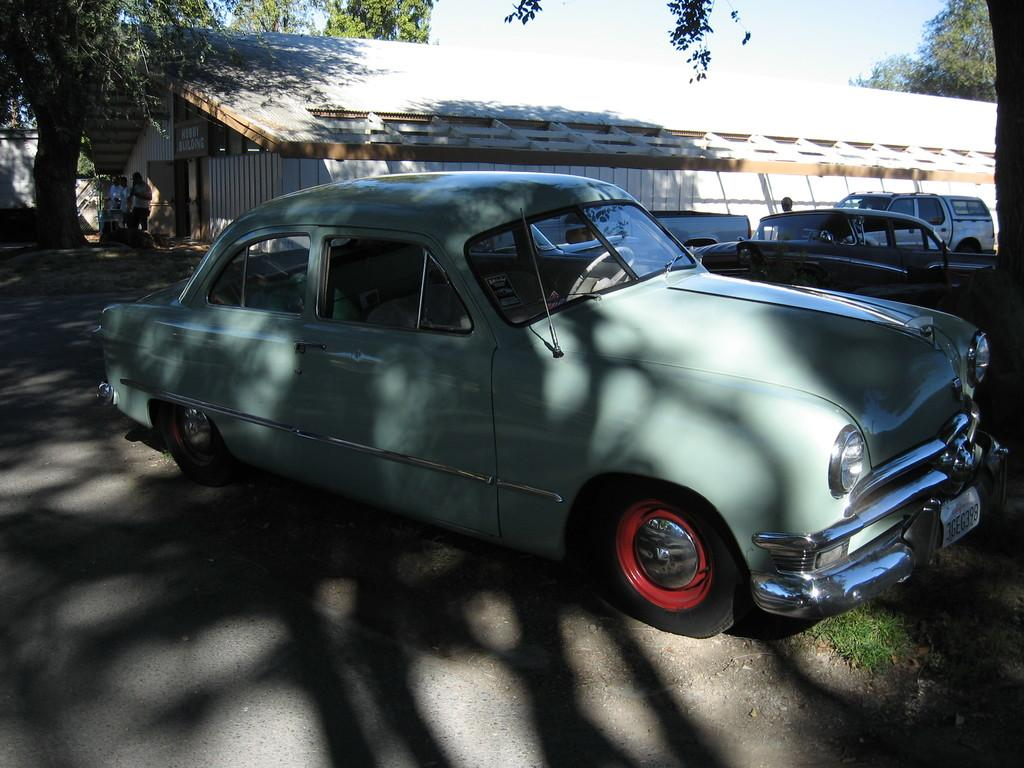What types of objects are on the ground in the image? There are vehicles on the ground in the image. What can be seen in the background of the image? In the background of the image, there are persons, trees, a board on a wall, a roof, and clouds in the sky. Can you describe the board on the wall in the background of the image? There is a board on a wall in the background of the image, but its content or purpose is not specified. What type of record is being played by the person in the image? There is no person or record present in the image; it only features vehicles on the ground and various elements in the background. 